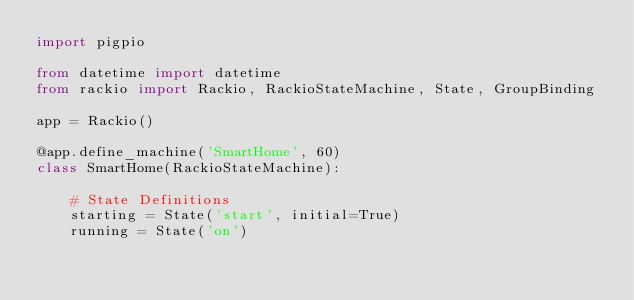Convert code to text. <code><loc_0><loc_0><loc_500><loc_500><_Python_>import pigpio

from datetime import datetime
from rackio import Rackio, RackioStateMachine, State, GroupBinding

app = Rackio()

@app.define_machine('SmartHome', 60)
class SmartHome(RackioStateMachine):

    # State Definitions
    starting = State('start', initial=True)
    running = State('on')</code> 